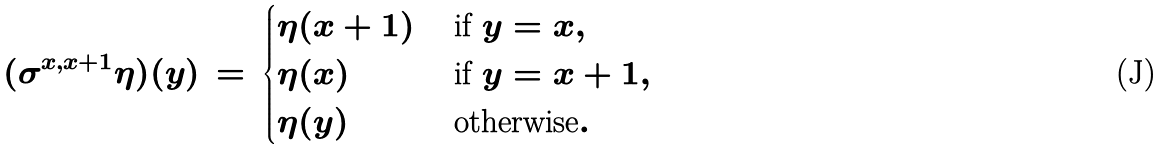Convert formula to latex. <formula><loc_0><loc_0><loc_500><loc_500>( \sigma ^ { x , x + 1 } \eta ) ( y ) \, = \, \begin{cases} \eta ( x + 1 ) & \text { if } y = x , \\ \eta ( x ) & \text { if } y = x + 1 , \\ \eta ( y ) & \text { otherwise} . \end{cases}</formula> 